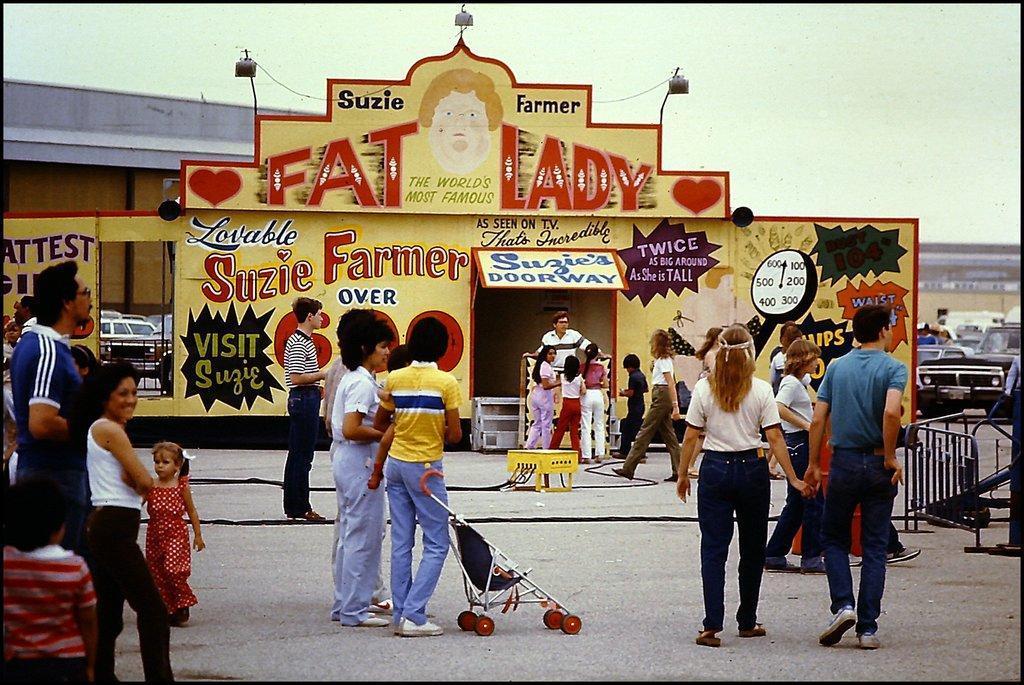Please provide a concise description of this image. In this image we can see a few people, there is a trolley, there is a board with some text and images on it, there is a house, there is a rack, box in the middle of the image, there are few vehicles, also we can see the sky. 